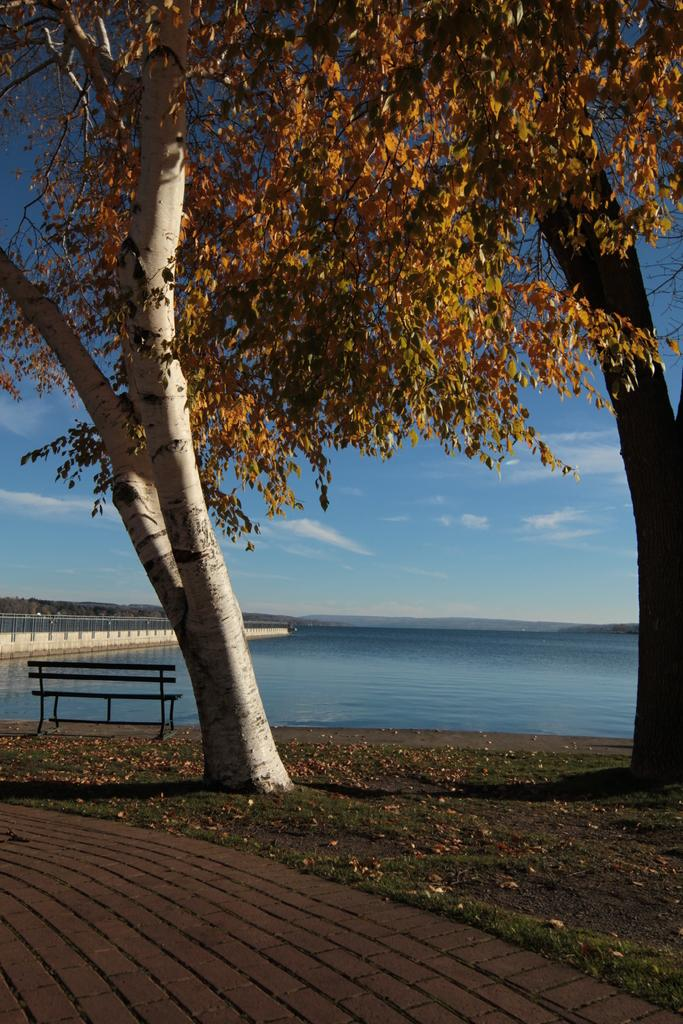What type of seating is visible in the image? There is a bench in the image. What can be found on the ground in the image? Leaves and trees are present on the ground. What is visible in the background of the image? There is water and the sky visible in the background of the image. What is the condition of the sky in the image? Clouds are present in the sky. What type of account is being discussed in the image? There is no account being discussed in the image; it features a bench, leaves, trees, water, and the sky. How long does it take for the board to be completed in the image? There is no board being constructed or completed in the image. 